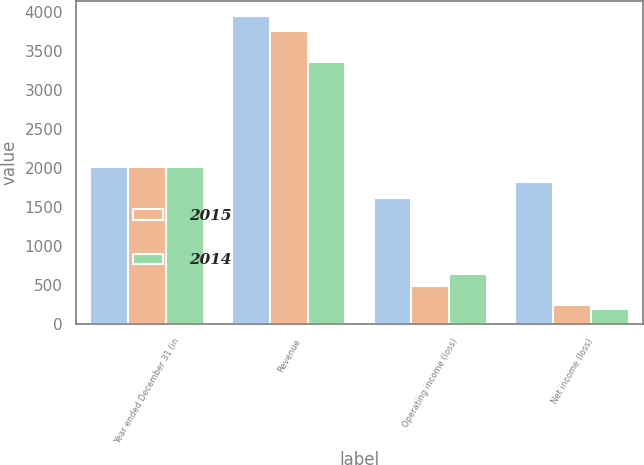Convert chart. <chart><loc_0><loc_0><loc_500><loc_500><stacked_bar_chart><ecel><fcel>Year ended December 31 (in<fcel>Revenue<fcel>Operating income (loss)<fcel>Net income (loss)<nl><fcel>nan<fcel>2015<fcel>3944<fcel>1609<fcel>1820<nl><fcel>2015<fcel>2014<fcel>3756<fcel>483<fcel>243<nl><fcel>2014<fcel>2013<fcel>3360<fcel>645<fcel>188<nl></chart> 